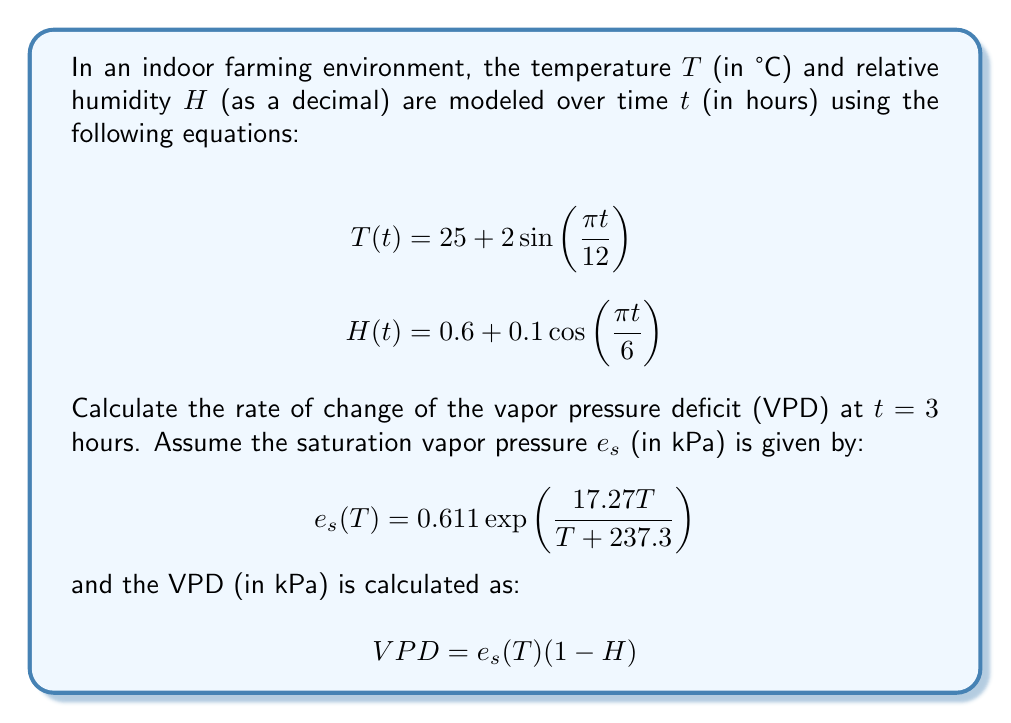Provide a solution to this math problem. To solve this problem, we need to follow these steps:

1) First, calculate T(3) and H(3):
   $$T(3) = 25 + 2\sin(\frac{\pi \cdot 3}{12}) = 25 + 2\sin(\frac{\pi}{4}) = 25 + 2 \cdot 0.7071 = 26.4142$$
   $$H(3) = 0.6 + 0.1\cos(\frac{\pi \cdot 3}{6}) = 0.6 + 0.1\cos(\frac{\pi}{2}) = 0.6$$

2) Calculate $e_s(T(3))$:
   $$e_s(26.4142) = 0.611 \exp(\frac{17.27 \cdot 26.4142}{26.4142 + 237.3}) = 3.4635$$

3) Calculate VPD at t = 3:
   $$VPD(3) = 3.4635 \cdot (1 - 0.6) = 1.3854$$

4) To find the rate of change of VPD, we need to differentiate VPD with respect to t:
   $$\frac{d}{dt}VPD = \frac{d}{dt}[e_s(T(t))(1-H(t))]$$
   $$= \frac{de_s}{dT} \cdot \frac{dT}{dt} \cdot (1-H(t)) - e_s(T(t)) \cdot \frac{dH}{dt}$$

5) Calculate $\frac{de_s}{dT}$:
   $$\frac{de_s}{dT} = e_s(T) \cdot \frac{17.27 \cdot 237.3}{(T + 237.3)^2}$$
   At T = 26.4142: $\frac{de_s}{dT} = 3.4635 \cdot \frac{17.27 \cdot 237.3}{(26.4142 + 237.3)^2} = 0.2493$

6) Calculate $\frac{dT}{dt}$ and $\frac{dH}{dt}$ at t = 3:
   $$\frac{dT}{dt} = 2\cos(\frac{\pi t}{12}) \cdot \frac{\pi}{12} = 2\cos(\frac{\pi}{4}) \cdot \frac{\pi}{12} = 0.4636$$
   $$\frac{dH}{dt} = -0.1\sin(\frac{\pi t}{6}) \cdot \frac{\pi}{6} = -0.1\sin(\frac{\pi}{2}) \cdot \frac{\pi}{6} = -0.0524$$

7) Now we can calculate $\frac{d}{dt}VPD$ at t = 3:
   $$\frac{d}{dt}VPD = 0.2493 \cdot 0.4636 \cdot (1-0.6) - 3.4635 \cdot (-0.0524)$$
   $$= 0.0462 + 0.1815 = 0.2277$$

Therefore, the rate of change of VPD at t = 3 hours is 0.2277 kPa/hour.
Answer: 0.2277 kPa/hour 